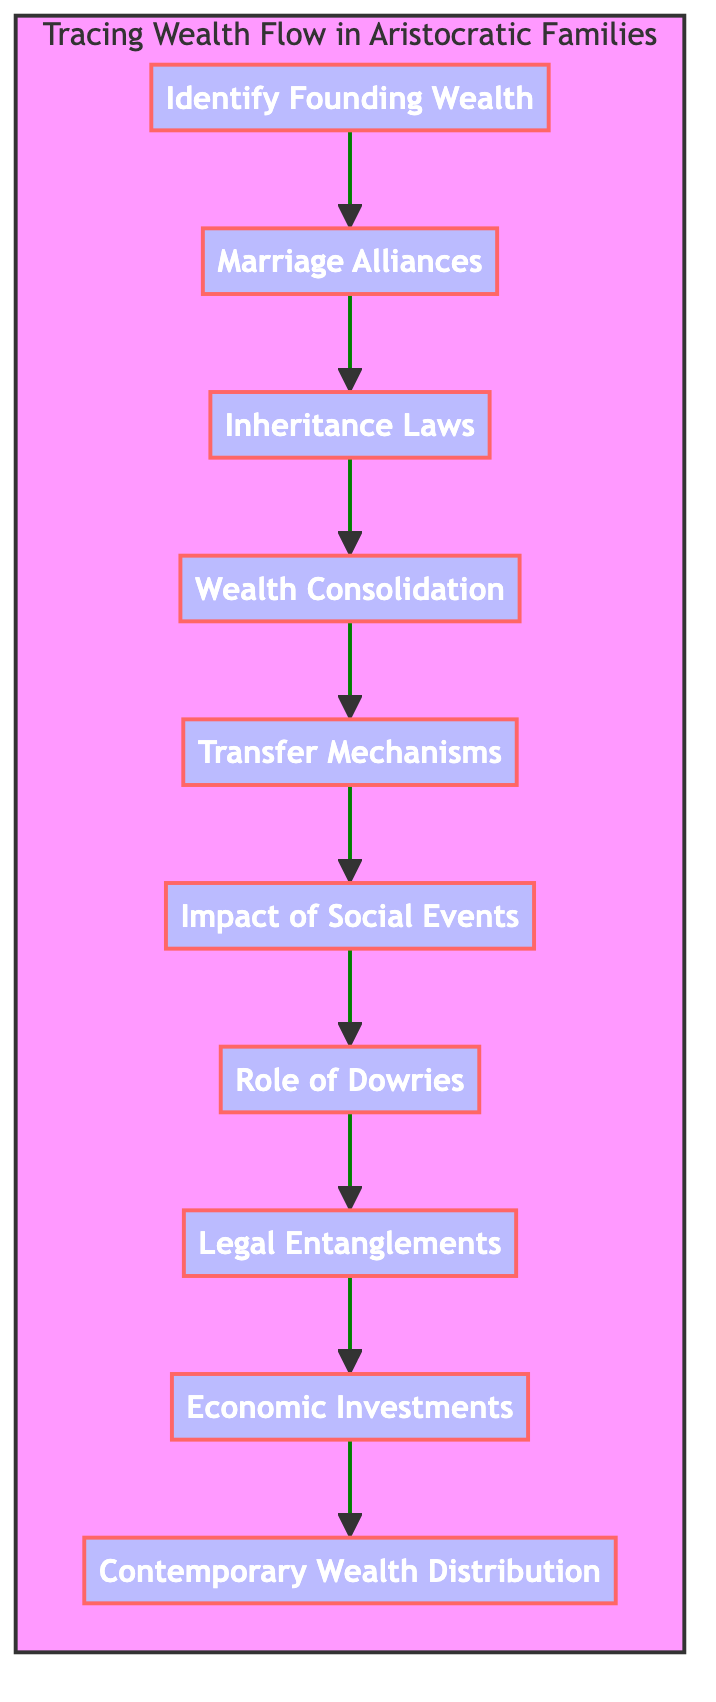What is the first step in tracing wealth flow? The first step in the flow chart is "Identify Founding Wealth," which signifies the initial action to begin tracing the flow of wealth through generations.
Answer: Identify Founding Wealth How many nodes are present in the diagram? The diagram outlines ten specific steps, or nodes, in tracing wealth flow.
Answer: Ten Which step follows "Transfer Mechanisms"? The step that follows "Transfer Mechanisms" is "Impact of Social Events," indicating that after wealth transfer, the influence of social events should be considered.
Answer: Impact of Social Events What is the last step in the flow of wealth? The last step in the flow chart is "Contemporary Wealth Distribution," reflecting the end analysis after tracing the flow of wealth.
Answer: Contemporary Wealth Distribution How does "Marriage Alliances" relate to "Wealth Consolidation"? "Marriage Alliances" leads to "Wealth Consolidation," implying that marriages are strategic to manage and build wealth across generations.
Answer: Leads to What are two examples of "Inheritance Laws"? The two examples provided for "Inheritance Laws" are "Primogeniture" and "Salic Law," representing different rules governing inheritance.
Answer: Primogeniture and Salic Law What is the significance of "Legal Entanglements" in wealth distribution? "Legal Entanglements" addresses how disputes, like inheritance conflicts, may impact the distribution of wealth among heirs, emphasizing its critical role.
Answer: Discusses disputes How does the "Role of Dowries" fit within the overall flow of wealth? The "Role of Dowries" is positioned after "Impact of Social Events," suggesting that the agreements formed through dowries can affect wealth distribution in response to social changes.
Answer: Positioned after What is an example of a method used for "Wealth Consolidation"? One method described for "Wealth Consolidation" is "Establishing trusts or estates," which helps preserve and grow family wealth over time.
Answer: Establishing trusts or estates Which process follows "Economic Investments"? "Contemporary Wealth Distribution" follows "Economic Investments," indicating the final assessment of wealth considering financial strategies implemented in previous steps.
Answer: Contemporary Wealth Distribution 